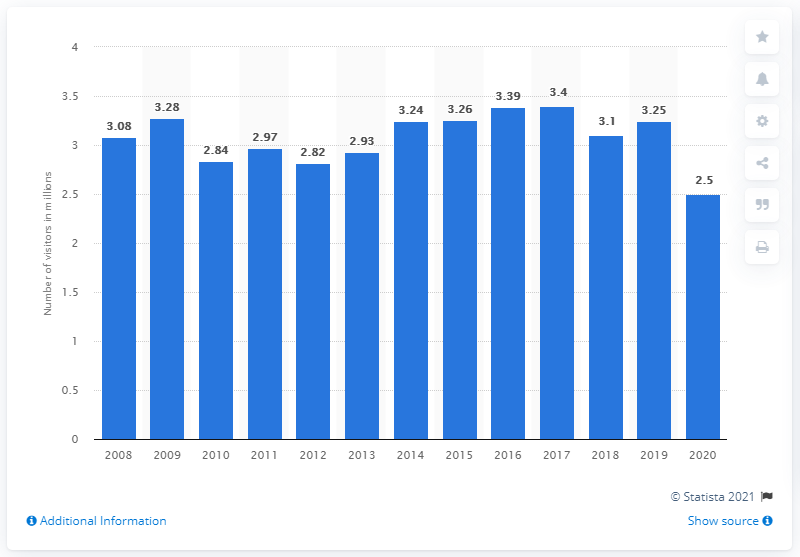Identify some key points in this picture. In 2020, COVID-19 was found to have contained approximately 2.5 visitors to Olympic National Park. 